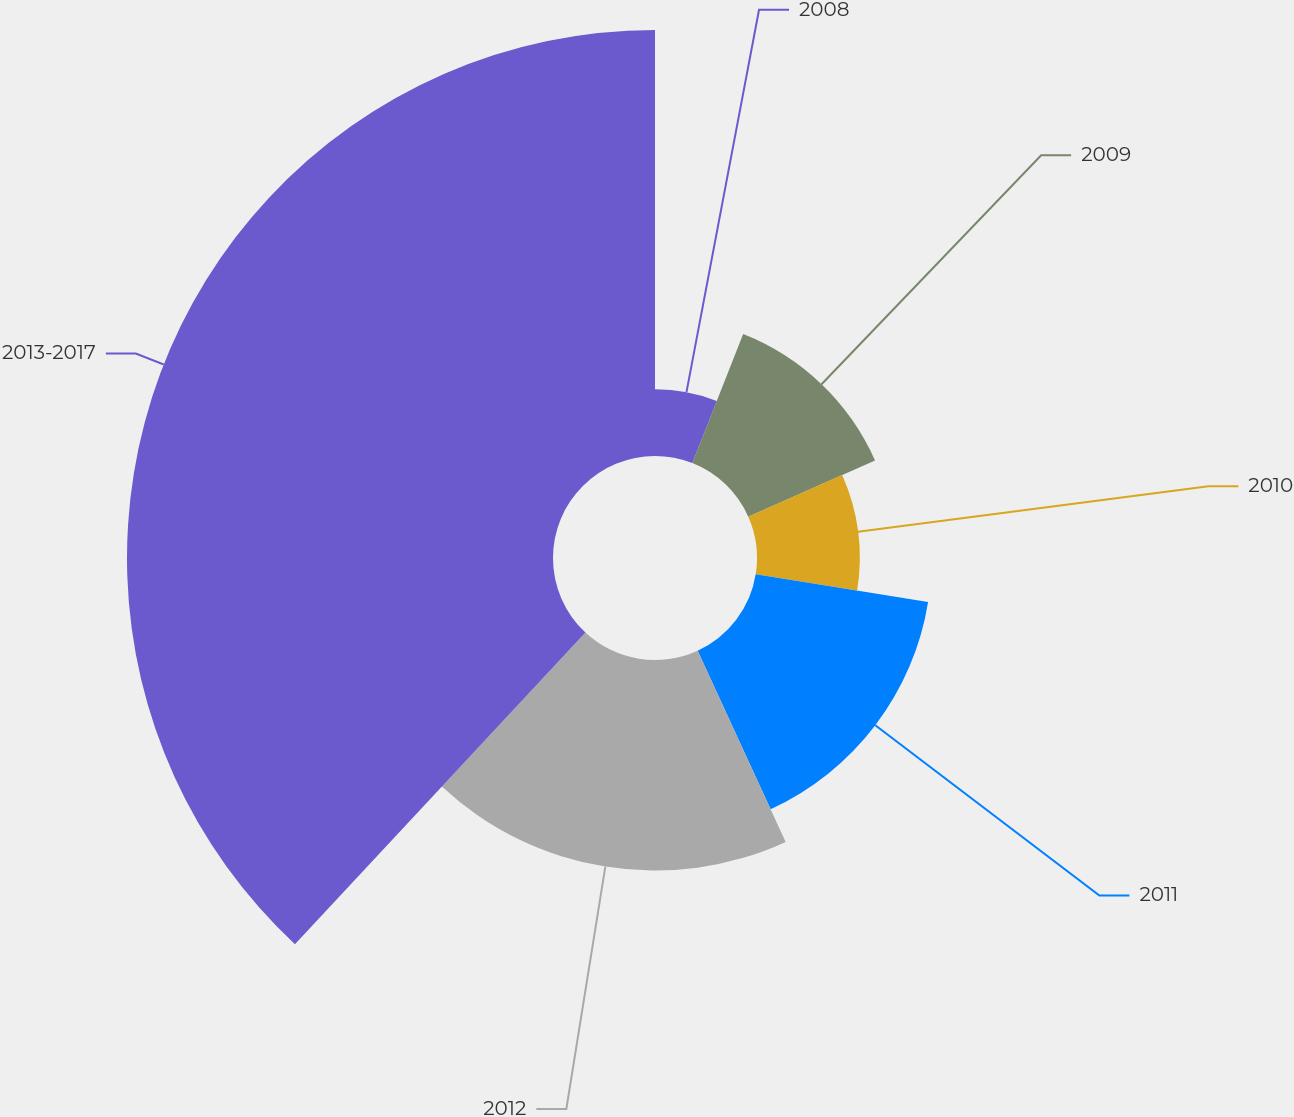Convert chart to OTSL. <chart><loc_0><loc_0><loc_500><loc_500><pie_chart><fcel>2008<fcel>2009<fcel>2010<fcel>2011<fcel>2012<fcel>2013-2017<nl><fcel>5.97%<fcel>12.39%<fcel>9.18%<fcel>15.6%<fcel>18.81%<fcel>38.06%<nl></chart> 